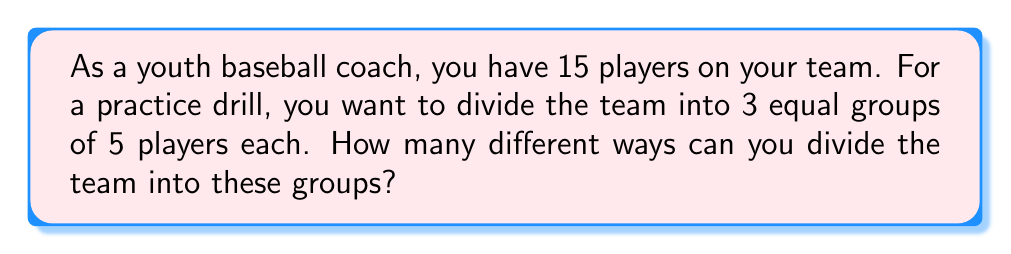Could you help me with this problem? Let's approach this step-by-step:

1) This problem is a combination of choosing groups without order, which can be solved using the concept of Stirling numbers of the second kind and multiplying by factorials.

2) We can think of this as first choosing 5 players for the first group, then 5 from the remaining 10 for the second group, and the last 5 automatically form the third group.

3) The number of ways to choose the first group is $\binom{15}{5}$.

4) After choosing the first group, we need to choose 5 from the remaining 10 for the second group, which is $\binom{10}{5}$.

5) However, this counts each arrangement multiple times because the order of the groups doesn't matter. We need to divide by the number of ways to arrange 3 groups, which is 3! = 6.

6) Therefore, the formula for this problem is:

   $$\frac{\binom{15}{5} \cdot \binom{10}{5}}{3!}$$

7) Let's calculate:
   $$\binom{15}{5} = \frac{15!}{5!(15-5)!} = \frac{15!}{5!10!} = 3003$$
   $$\binom{10}{5} = \frac{10!}{5!(10-5)!} = \frac{10!}{5!5!} = 252$$

8) Putting it all together:
   $$\frac{3003 \cdot 252}{6} = \frac{756756}{6} = 126126$$

Therefore, there are 126,126 different ways to divide the team into 3 equal groups of 5 players each.
Answer: 126126 